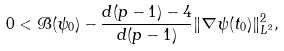<formula> <loc_0><loc_0><loc_500><loc_500>0 < \mathcal { B } ( \psi _ { 0 } ) - \frac { d ( p - 1 ) - 4 } { d ( p - 1 ) } \| \nabla \psi ( t _ { 0 } ) \| _ { L ^ { 2 } } ^ { 2 } ,</formula> 